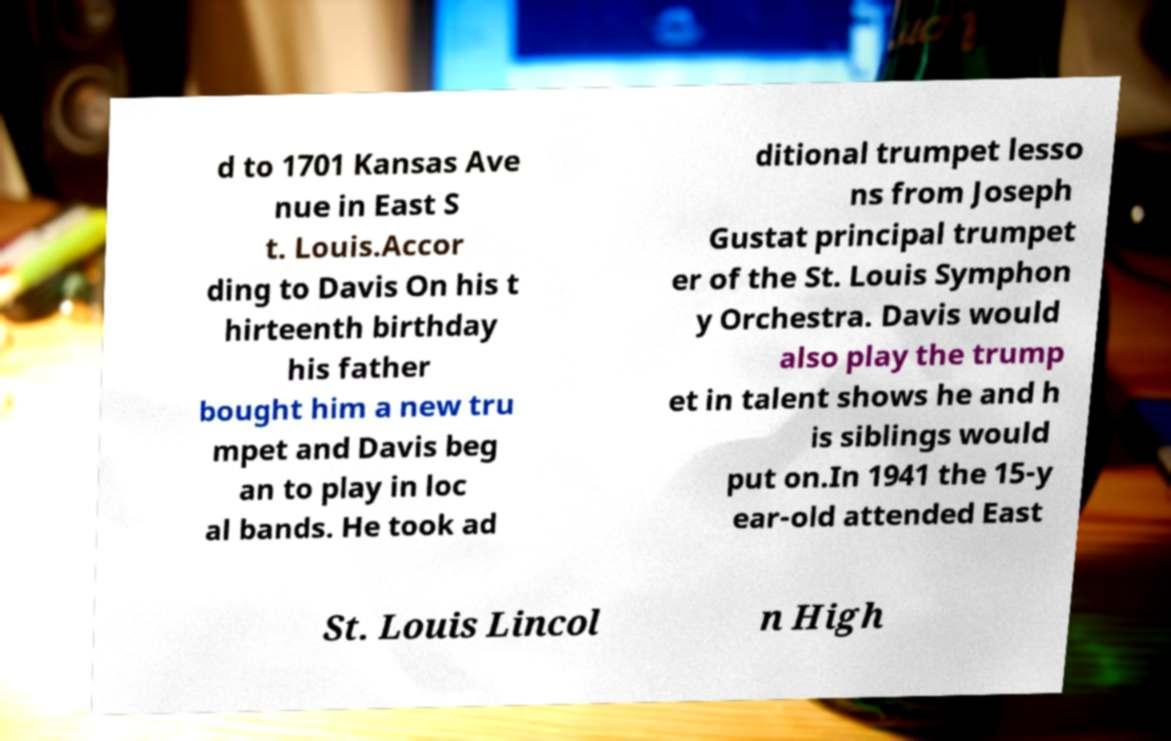Could you assist in decoding the text presented in this image and type it out clearly? d to 1701 Kansas Ave nue in East S t. Louis.Accor ding to Davis On his t hirteenth birthday his father bought him a new tru mpet and Davis beg an to play in loc al bands. He took ad ditional trumpet lesso ns from Joseph Gustat principal trumpet er of the St. Louis Symphon y Orchestra. Davis would also play the trump et in talent shows he and h is siblings would put on.In 1941 the 15-y ear-old attended East St. Louis Lincol n High 